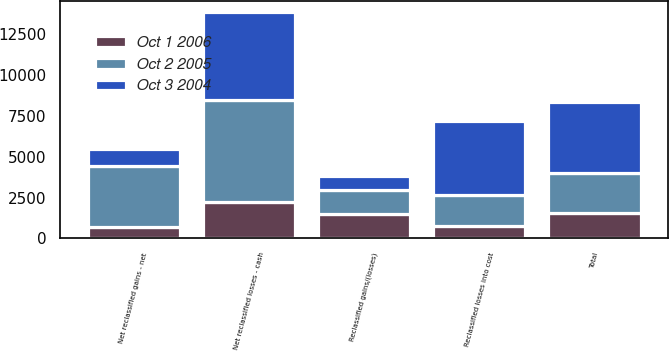Convert chart to OTSL. <chart><loc_0><loc_0><loc_500><loc_500><stacked_bar_chart><ecel><fcel>Reclassified gains/(losses)<fcel>Reclassified losses into cost<fcel>Net reclassified losses - cash<fcel>Net reclassified gains - net<fcel>Total<nl><fcel>Oct 2 2005<fcel>1489<fcel>1912.5<fcel>6209<fcel>3754<fcel>2455<nl><fcel>Oct 3 2004<fcel>843<fcel>4535<fcel>5378<fcel>1058<fcel>4320<nl><fcel>Oct 1 2006<fcel>1488<fcel>761<fcel>2249<fcel>673<fcel>1576<nl></chart> 